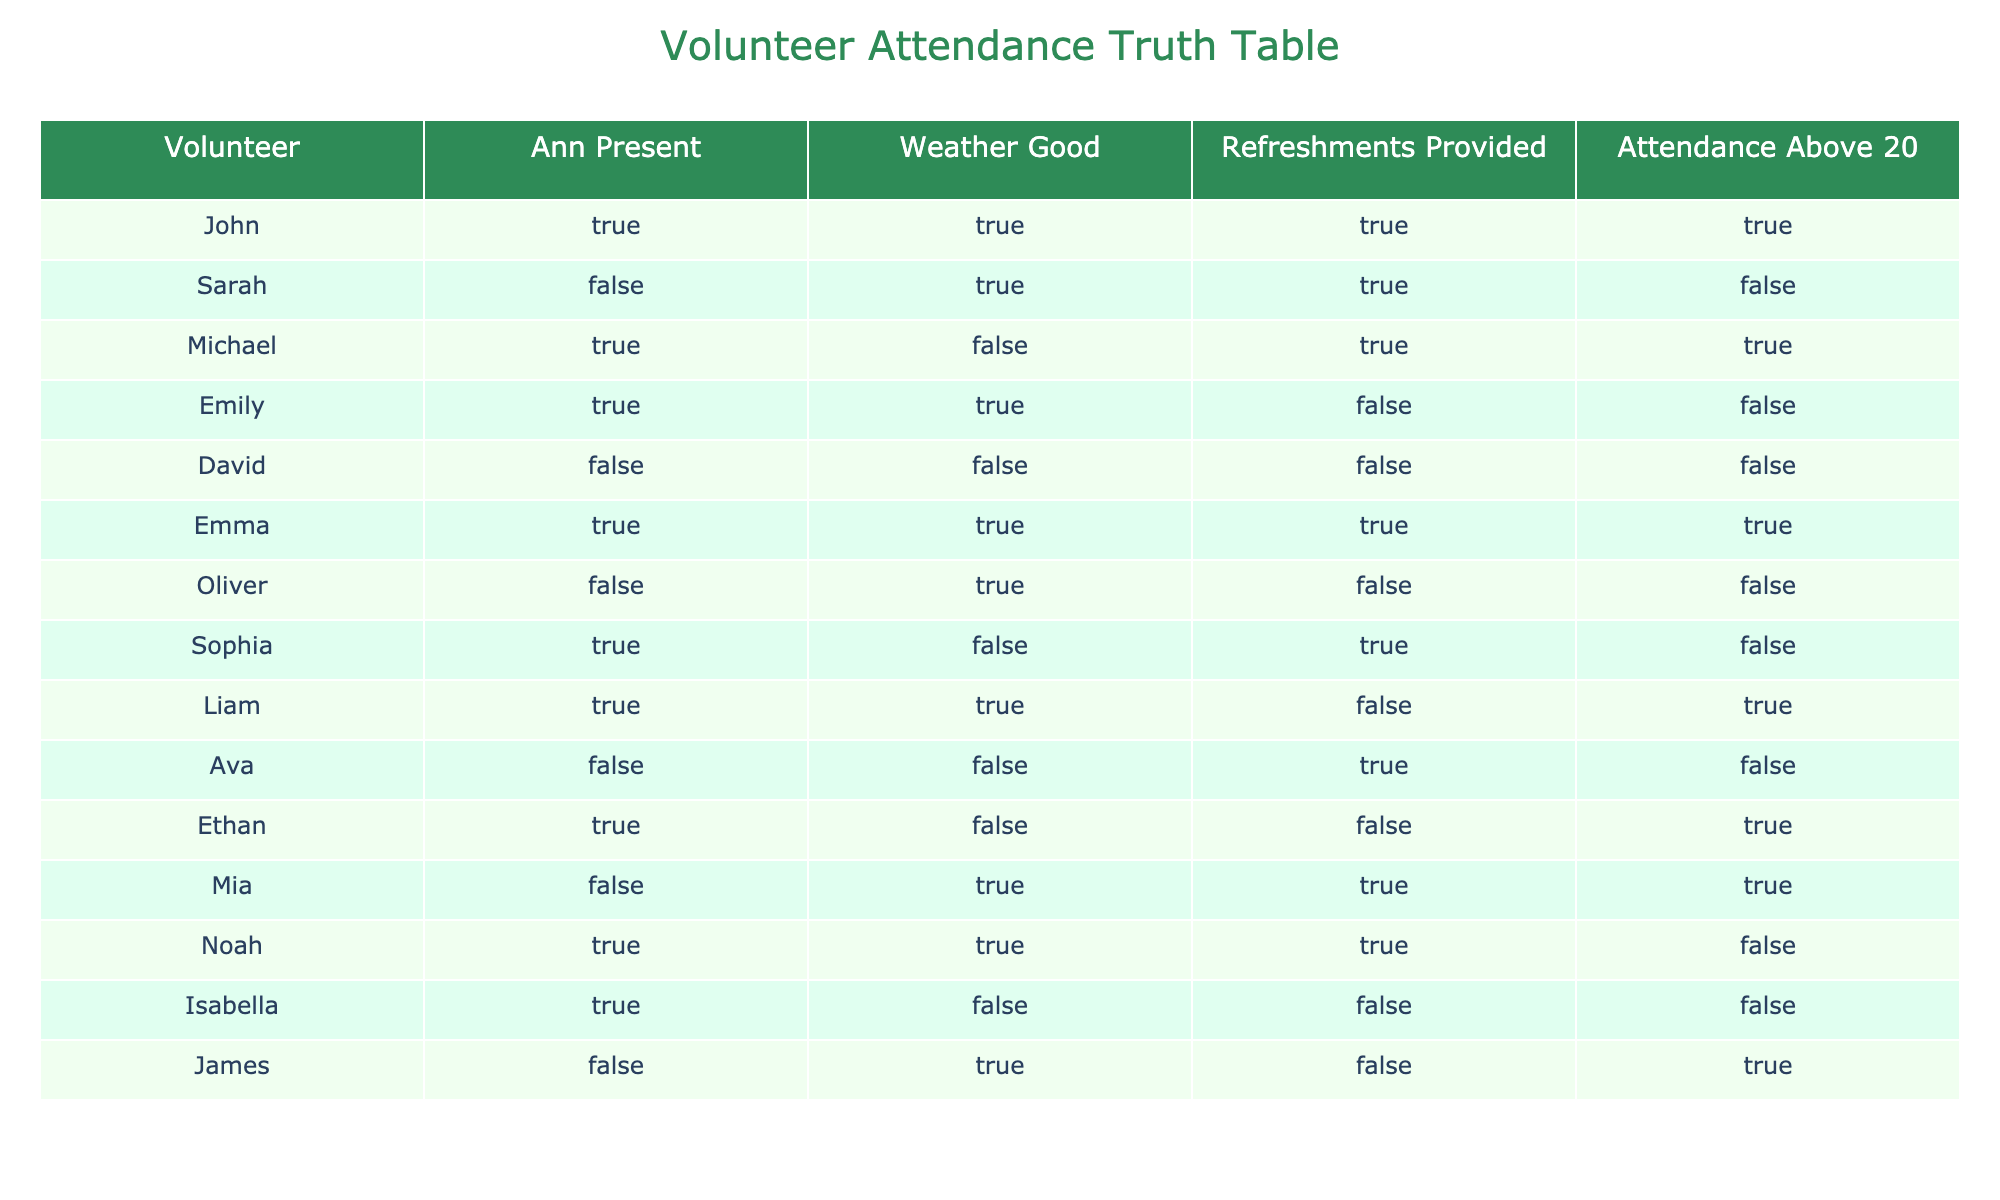What percentage of the volunteers were present during the events? There are 15 volunteers listed. To find the percentage, we need to count how many were present (TRUE in the "Ann Present" column). In this case, there are 9 TRUE values. The percentage can be calculated as (9/15) * 100 = 60%.
Answer: 60% How many times was the attendance above 20? We need to count the number of times the "Attendance Above 20" column has a TRUE value. Scanning through the table, we find 7 such instances.
Answer: 7 Is there a volunteer named Mia who was present during the clean-ups when the weather was good? Looking at the table, Mia is listed as FALSE for "Ann Present" when the weather was good (TRUE) in her row. Therefore, she was not present when the weather was good.
Answer: No Which volunteer had refreshments provided but was not present? Referring to the "Refreshments Provided" column, we find that Sarah, Oliver, and Ava had refreshments but were marked as FALSE in the "Ann Present" column. Therefore, Sarah and Oliver meet this criteria.
Answer: Sarah, Oliver How many volunteers were present when the attendance was above 20 and refreshments were provided? We need to filter the table for rows where both "Attendance Above 20" and "Refreshments Provided" are TRUE. This occurs for John, Emma, and Mia. Thus, there are 3 volunteers who meet both criteria.
Answer: 3 What is the total number of volunteers who were present but did not have refreshments provided? We need to count the volunteers who have TRUE for "Ann Present" and FALSE for "Refreshments Provided". The volunteers who meet this criterion are Michael, Sophia, and Liam, making a total of 3 volunteers.
Answer: 3 Was there a scenario where the attendance was above 20 but the weather was bad? Checking the table, we discover that all instances where "Attendance Above 20" is TRUE correspond to rows with "Weather Good" as TRUE. Hence, there was no scenario with bad weather and attendance above 20.
Answer: No How many volunteers attended the events when both the weather was good and refreshments were provided? Filtering for both TRUE values in "Weather Good" and "Refreshments Provided", we look through the table. The relevant volunteers who attended are John, Emma, and Mia, resulting in a total of 3 attendees.
Answer: 3 